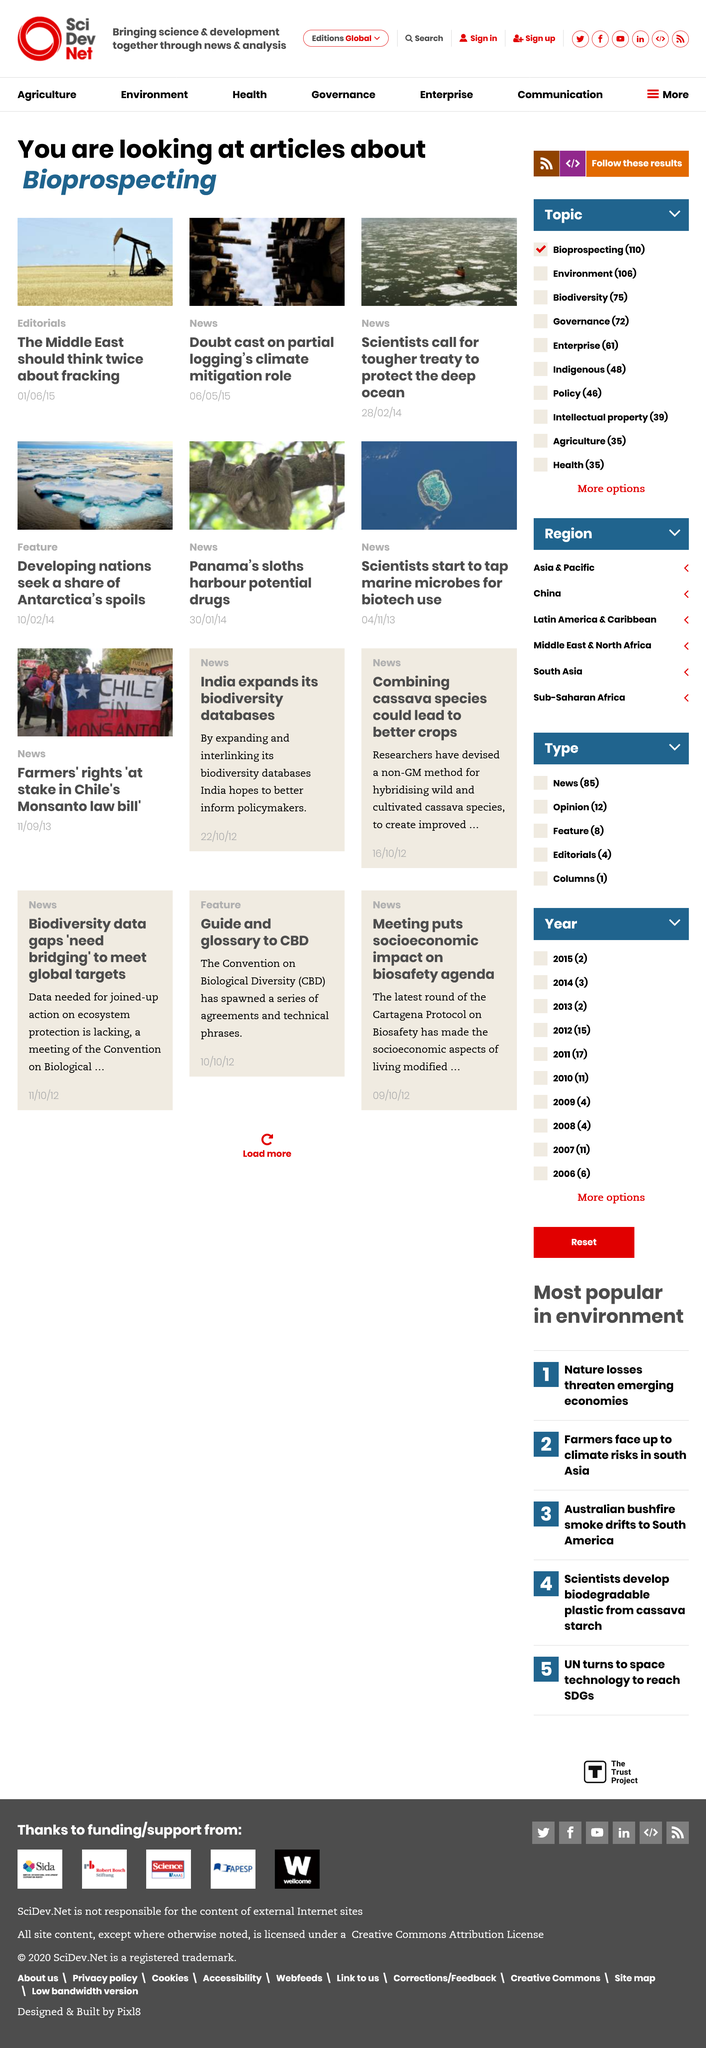Highlight a few significant elements in this photo. There are 3 articles on the page. In 2015, the features were published. We are currently reviewing articles on this page, specifically those that pertain to bioprospecting. 